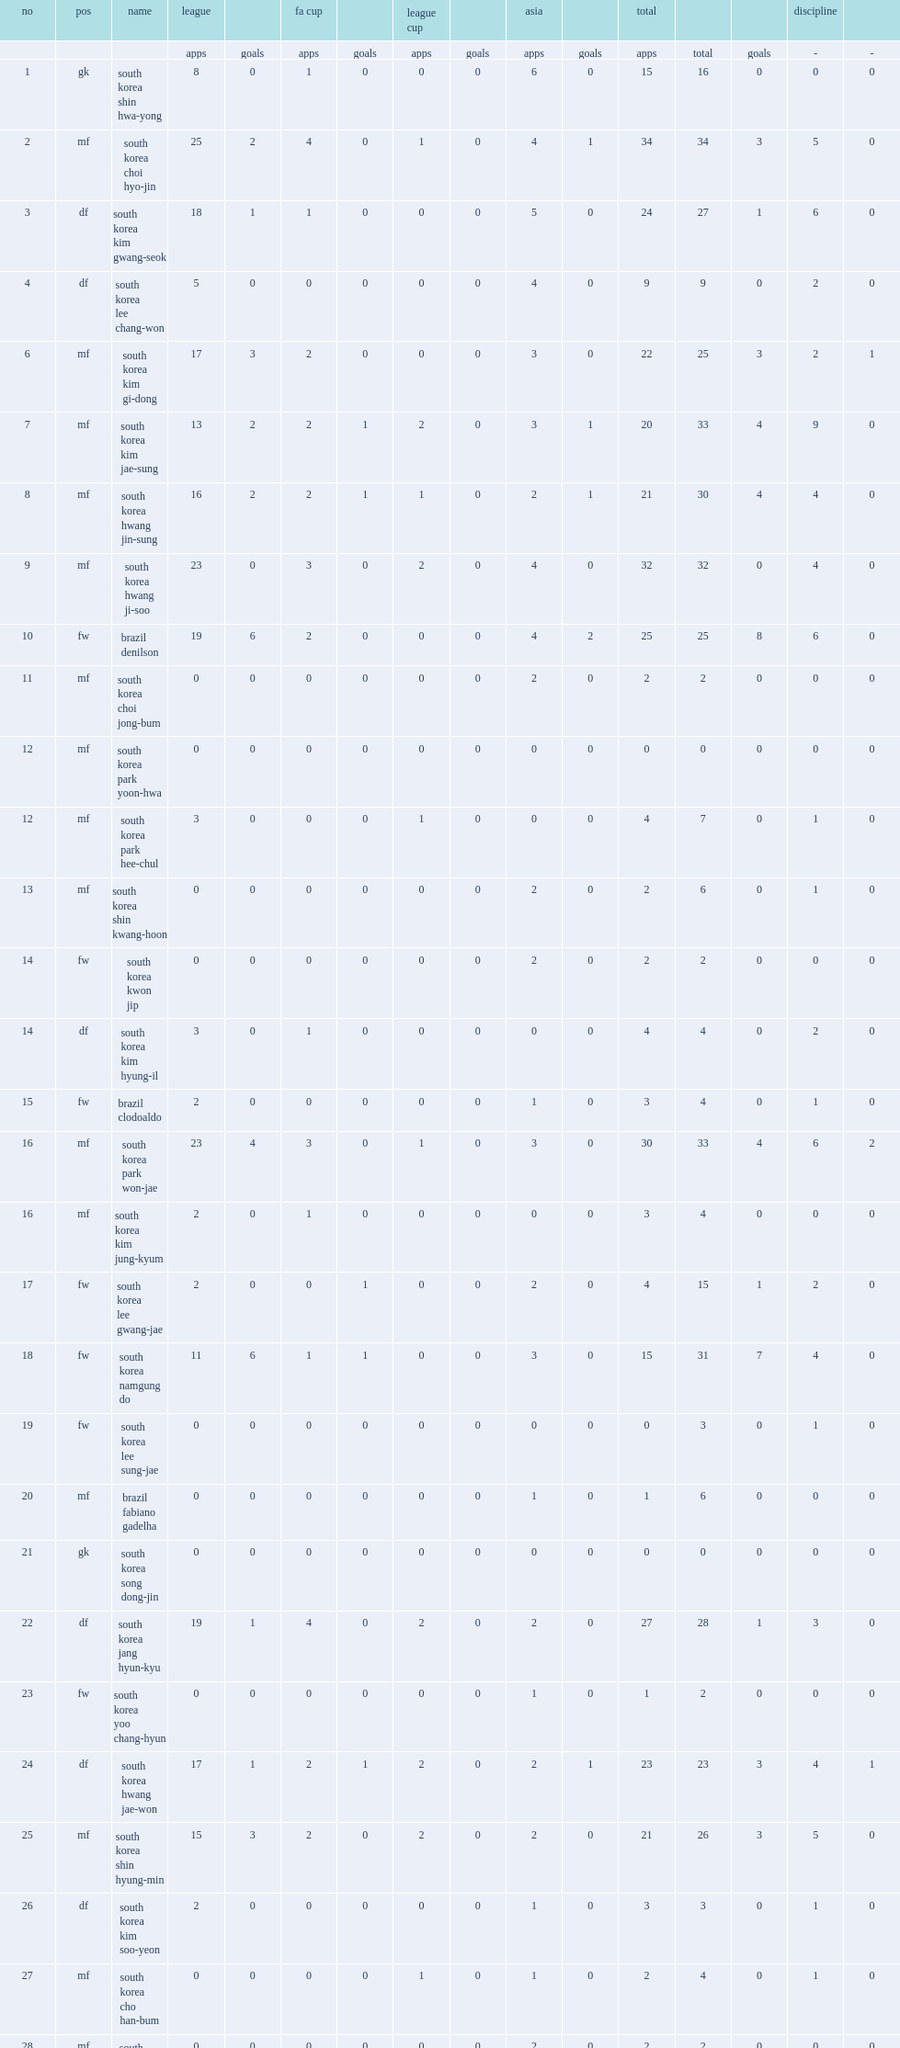List the clubs pohang steelers competed in. League league cup fa cup. 